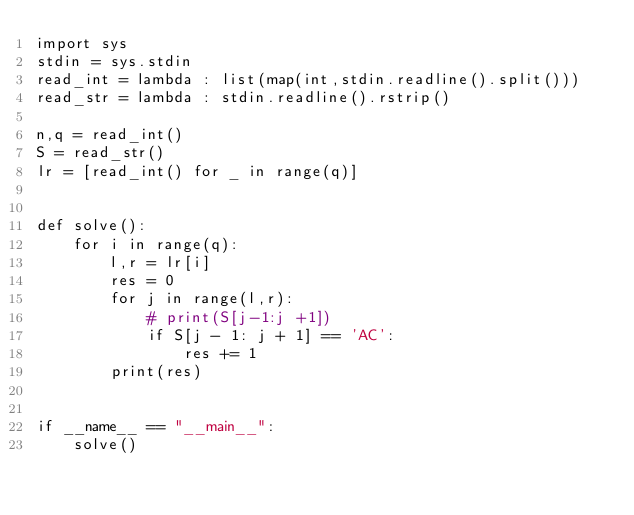Convert code to text. <code><loc_0><loc_0><loc_500><loc_500><_Python_>import sys
stdin = sys.stdin
read_int = lambda : list(map(int,stdin.readline().split()))
read_str = lambda : stdin.readline().rstrip()

n,q = read_int()
S = read_str()
lr = [read_int() for _ in range(q)]


def solve():
    for i in range(q):
        l,r = lr[i]
        res = 0
        for j in range(l,r):
            # print(S[j-1:j +1])
            if S[j - 1: j + 1] == 'AC':
                res += 1
        print(res)


if __name__ == "__main__":
    solve()</code> 